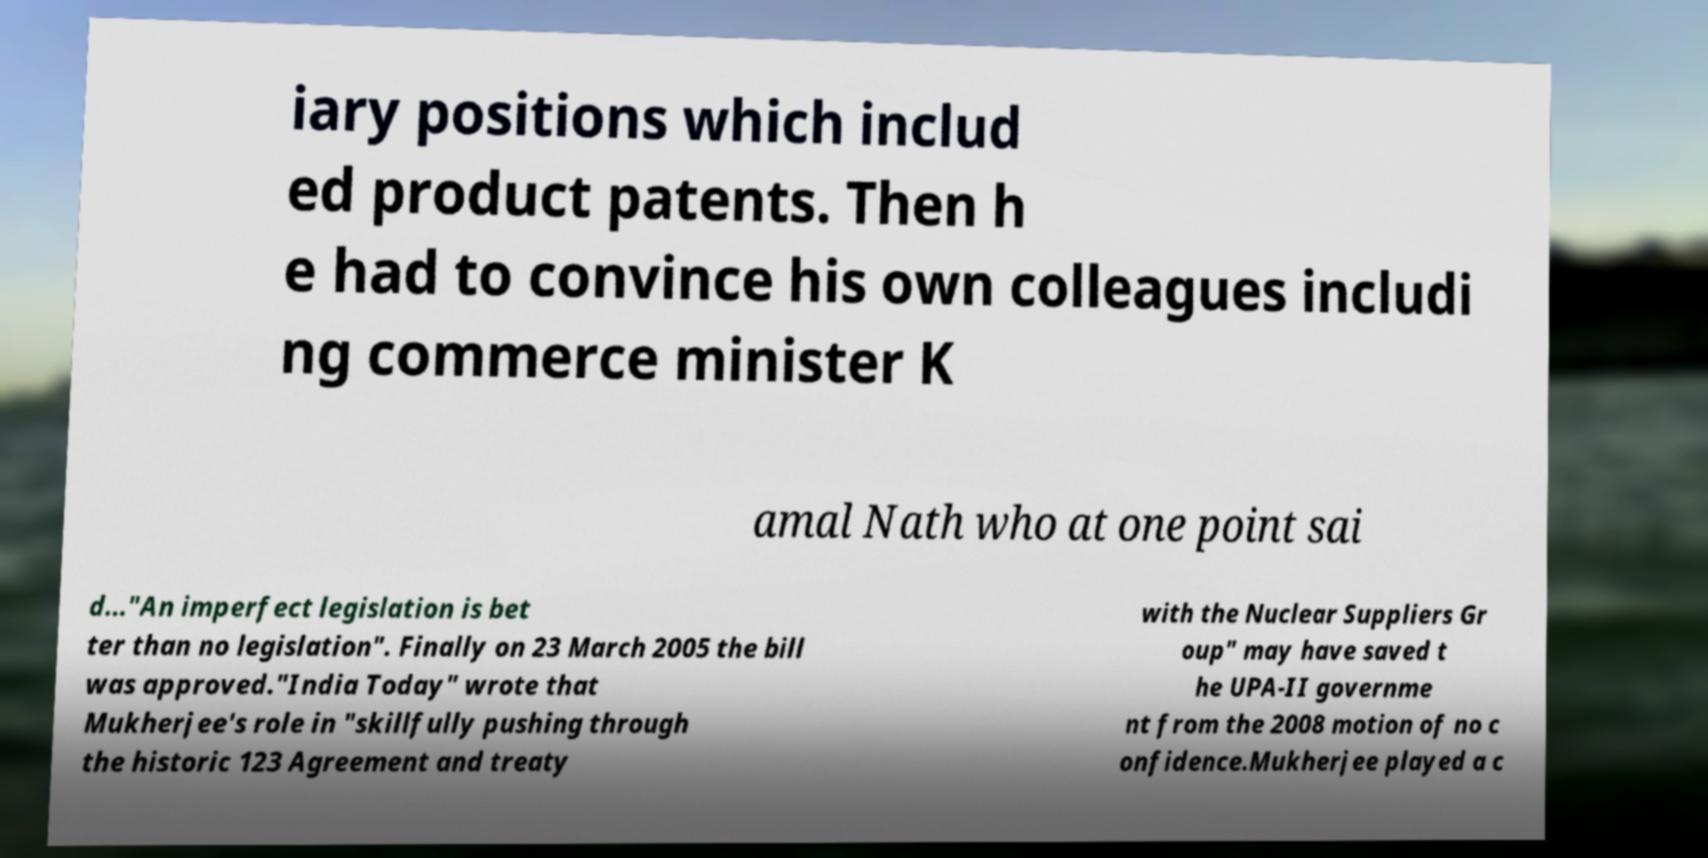Please identify and transcribe the text found in this image. iary positions which includ ed product patents. Then h e had to convince his own colleagues includi ng commerce minister K amal Nath who at one point sai d..."An imperfect legislation is bet ter than no legislation". Finally on 23 March 2005 the bill was approved."India Today" wrote that Mukherjee's role in "skillfully pushing through the historic 123 Agreement and treaty with the Nuclear Suppliers Gr oup" may have saved t he UPA-II governme nt from the 2008 motion of no c onfidence.Mukherjee played a c 